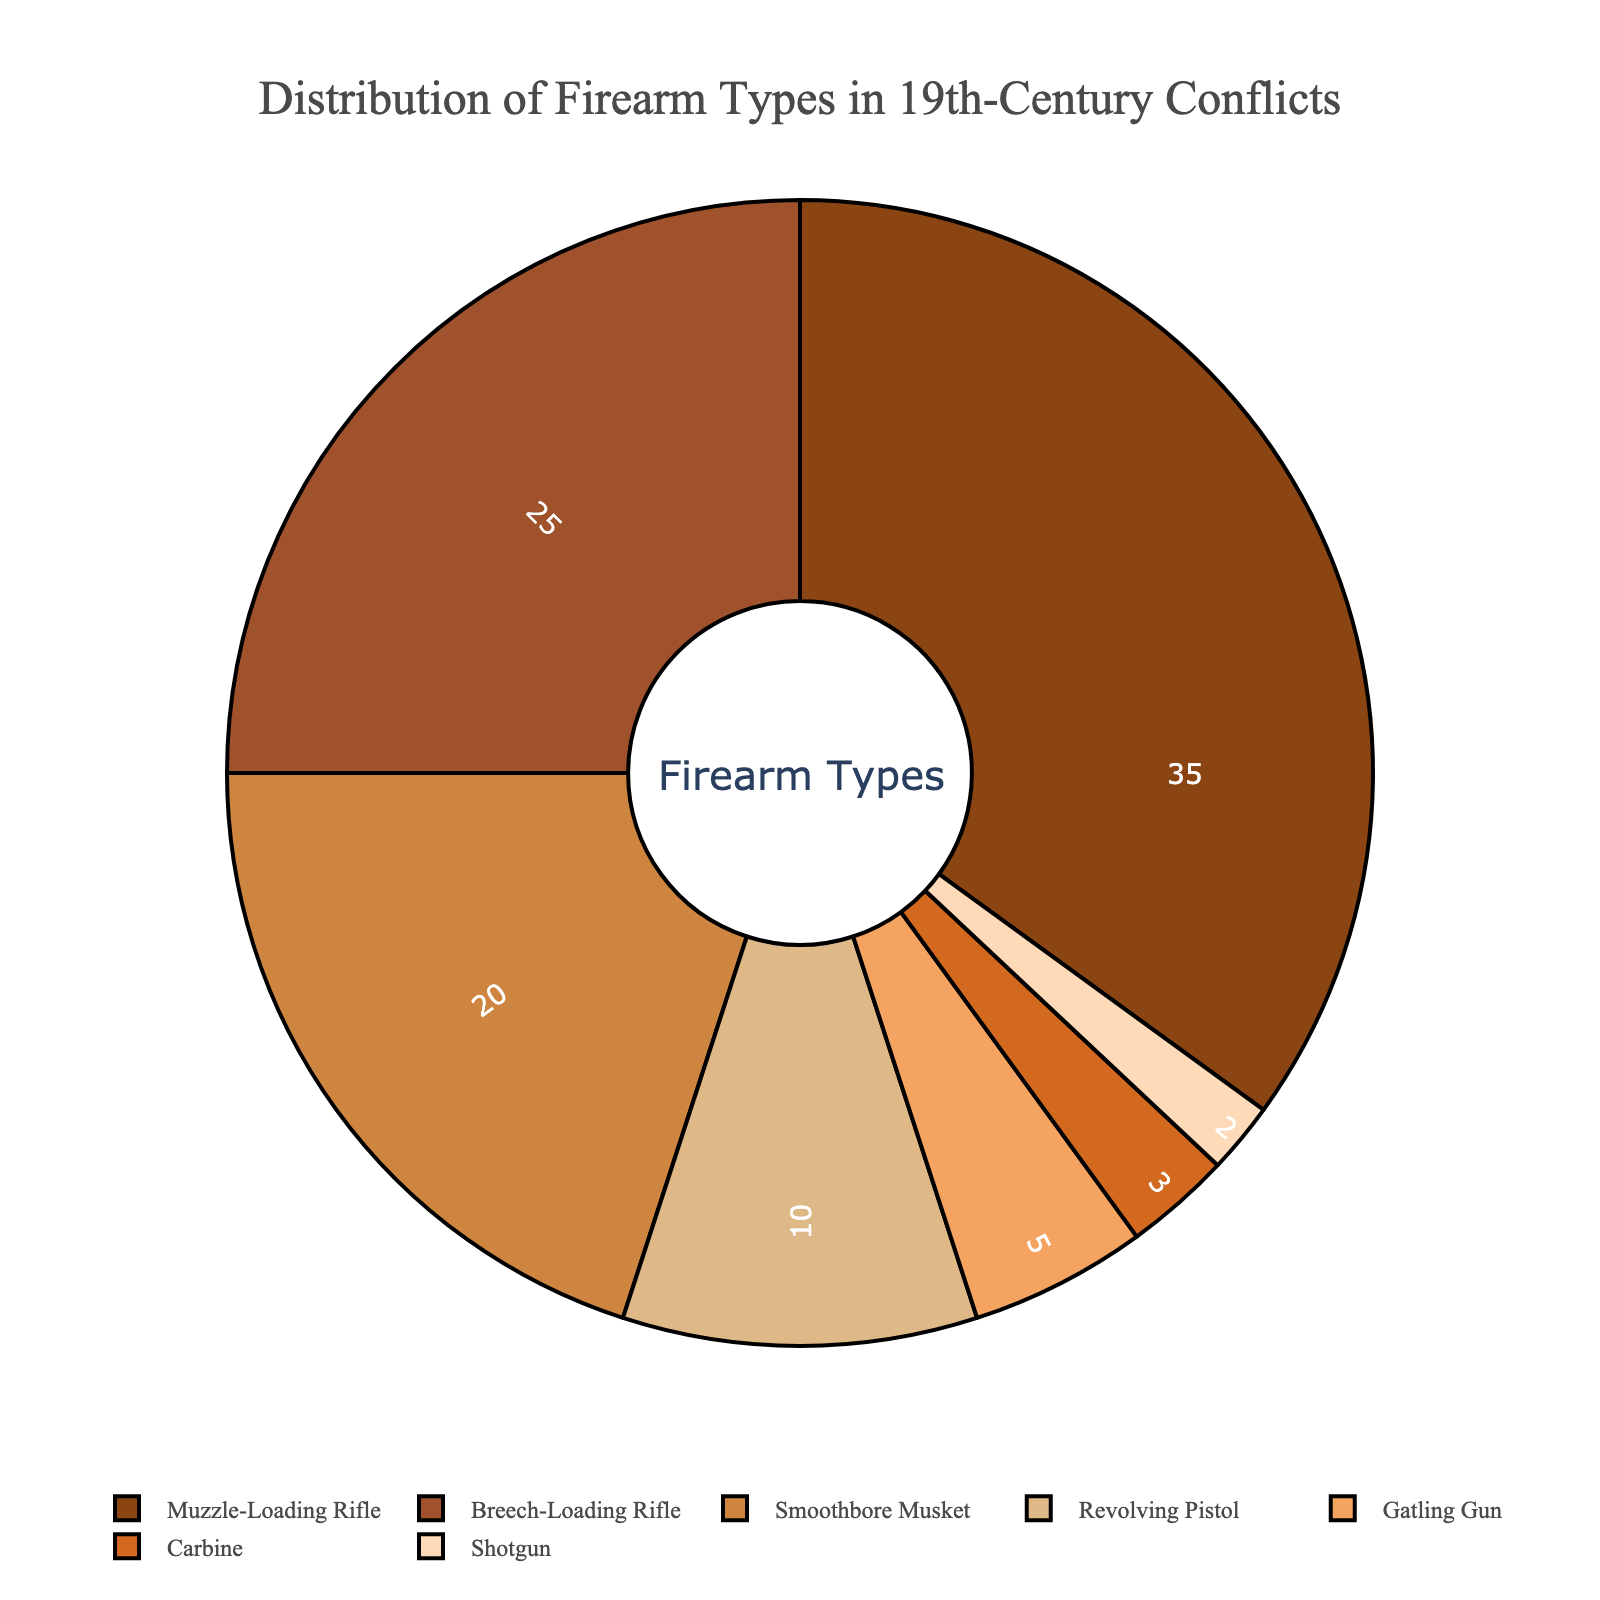What is the most common firearm type used in major 19th-century conflicts? To answer this, we identify the largest segment in the pie chart. The "Muzzle-Loading Rifle" segment has the largest percentage.
Answer: Muzzle-Loading Rifle What is the combined percentage of Revolving Pistols and Gatling Guns? Sum the percentage of Revolving Pistols (10%) and Gatling Guns (5%), resulting in 10% + 5% = 15%.
Answer: 15% Which firearm type is used the least? Find the smallest segment in the pie chart. The "Shotgun" segment is the smallest with a percentage of 2%.
Answer: Shotgun How much more common are Muzzle-Loading Rifles than Breech-Loading Rifles? Subtract the percentage of Breech-Loading Rifles (25%) from the percentage of Muzzle-Loading Rifles (35%) resulting in 35% - 25% = 10%.
Answer: 10% Among the firearm types used, which two combined make up less than 5% of the total? Identify segments that add up to less than 5%. The "Carbine" (3%) and "Shotgun" (2%) combined total 3% + 2% = 5%.
Answer: Carbine and Shotgun What percentage of the total do Smoothbore Muskets and Breech-Loading Rifles represent together? Sum the percentage of Smoothbore Muskets (20%) and Breech-Loading Rifles (25%) resulting in 20% + 25% = 45%.
Answer: 45% How does the percentage of Gatling Guns compare to that of Carbines? Compare the percentages directly; Gatling Guns are 5% and Carbines are 3%. Gatling Guns are more common than Carbines.
Answer: Gatling Guns are more common Which firearm type occupies a light brown segment in the pie chart? Locate the segment that is visually represented with a light brown color. The "DEB887" color (light brown) corresponds to the "Smoothbore Musket".
Answer: Smoothbore Musket If you add the percentages of Muzzle-Loading Rifles and Revolving Pistols, is the total more than half of the overall percentage? Sum the percentages of Muzzle-Loading Rifles (35%) and Revolving Pistols (10%) resulting in 35% + 10% = 45%, which is less than 50%.
Answer: No Out of the firearm types listed, which three combined make up more than half of the total percentage? Sum the three highest percentages: Muzzle-Loading Rifle (35%), Breech-Loading Rifle (25%), and Smoothbore Musket (20%) resulting in 35% + 25% + 20% = 80%, which is more than 50%.
Answer: Muzzle-Loading Rifle, Breech-Loading Rifle, and Smoothbore Musket 